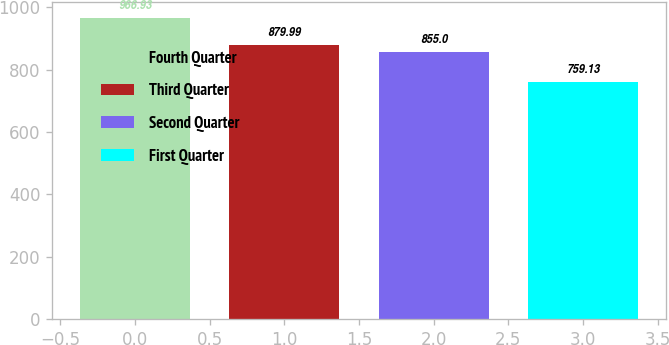Convert chart to OTSL. <chart><loc_0><loc_0><loc_500><loc_500><bar_chart><fcel>Fourth Quarter<fcel>Third Quarter<fcel>Second Quarter<fcel>First Quarter<nl><fcel>966.93<fcel>879.99<fcel>855<fcel>759.13<nl></chart> 